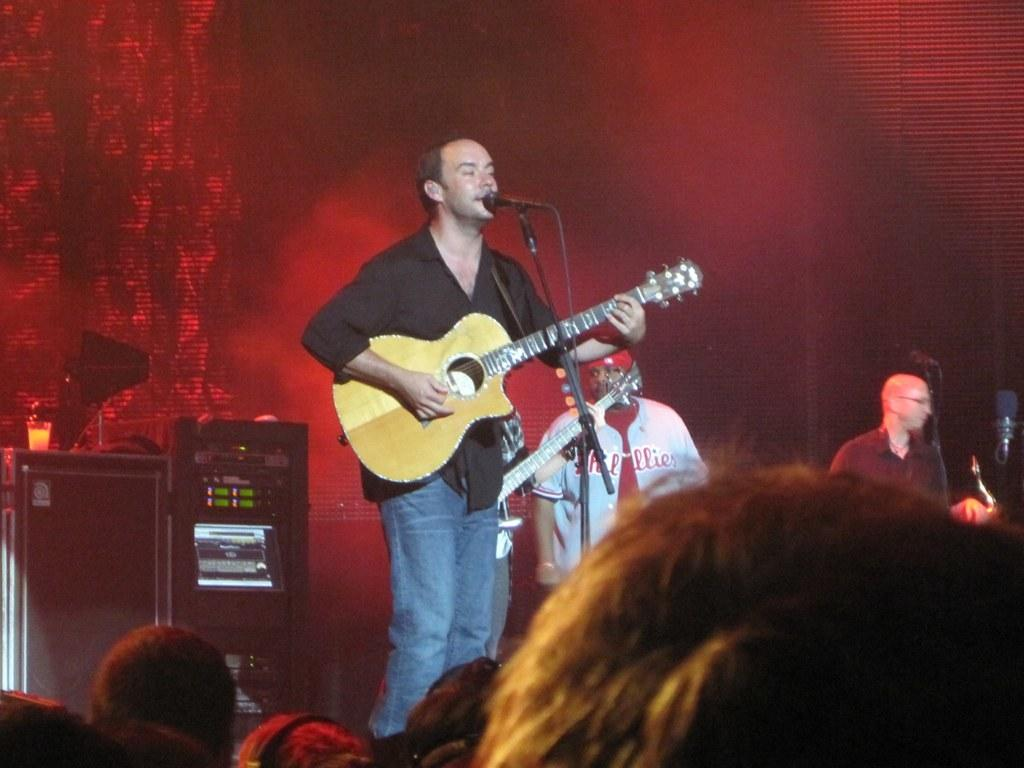What is the man in the image doing? The man in the image is standing and playing a guitar while singing with the help of a microphone. Are there any other people present in the image? Yes, there are people standing on one side of the man, and there is an audience watching the performance. What type of station is the man performing at in the image? There is no reference to a station in the image; it appears to be a performance setting, but not specifically at a station. 